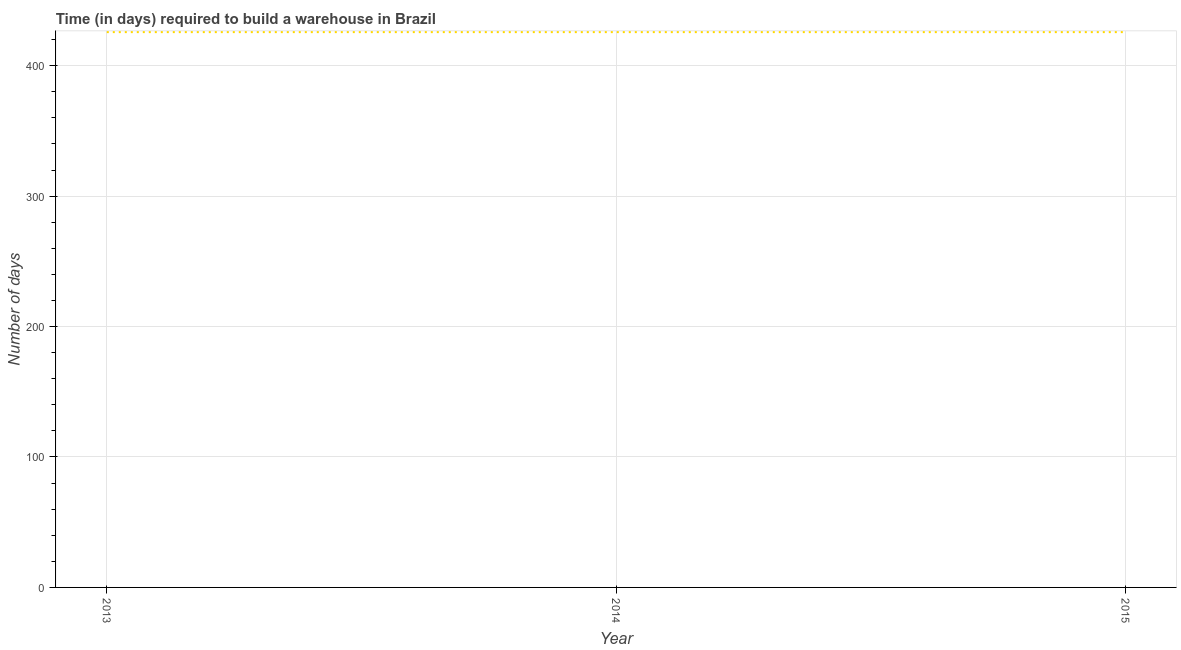What is the time required to build a warehouse in 2014?
Provide a succinct answer. 425.7. Across all years, what is the maximum time required to build a warehouse?
Your answer should be very brief. 425.7. Across all years, what is the minimum time required to build a warehouse?
Offer a terse response. 425.7. What is the sum of the time required to build a warehouse?
Provide a succinct answer. 1277.1. What is the difference between the time required to build a warehouse in 2013 and 2014?
Provide a succinct answer. 0. What is the average time required to build a warehouse per year?
Make the answer very short. 425.7. What is the median time required to build a warehouse?
Ensure brevity in your answer.  425.7. What is the ratio of the time required to build a warehouse in 2013 to that in 2015?
Your answer should be compact. 1. Is the time required to build a warehouse in 2013 less than that in 2014?
Your answer should be very brief. No. Is the difference between the time required to build a warehouse in 2014 and 2015 greater than the difference between any two years?
Your answer should be compact. Yes. What is the difference between the highest and the second highest time required to build a warehouse?
Provide a succinct answer. 0. In how many years, is the time required to build a warehouse greater than the average time required to build a warehouse taken over all years?
Your answer should be very brief. 0. Does the time required to build a warehouse monotonically increase over the years?
Your answer should be very brief. No. How many lines are there?
Your answer should be compact. 1. How many years are there in the graph?
Give a very brief answer. 3. Are the values on the major ticks of Y-axis written in scientific E-notation?
Give a very brief answer. No. Does the graph contain any zero values?
Give a very brief answer. No. Does the graph contain grids?
Keep it short and to the point. Yes. What is the title of the graph?
Offer a terse response. Time (in days) required to build a warehouse in Brazil. What is the label or title of the X-axis?
Keep it short and to the point. Year. What is the label or title of the Y-axis?
Your answer should be very brief. Number of days. What is the Number of days of 2013?
Give a very brief answer. 425.7. What is the Number of days of 2014?
Your answer should be very brief. 425.7. What is the Number of days in 2015?
Make the answer very short. 425.7. What is the difference between the Number of days in 2013 and 2014?
Offer a very short reply. 0. What is the difference between the Number of days in 2013 and 2015?
Your response must be concise. 0. What is the difference between the Number of days in 2014 and 2015?
Your answer should be compact. 0. What is the ratio of the Number of days in 2013 to that in 2014?
Make the answer very short. 1. What is the ratio of the Number of days in 2013 to that in 2015?
Ensure brevity in your answer.  1. 